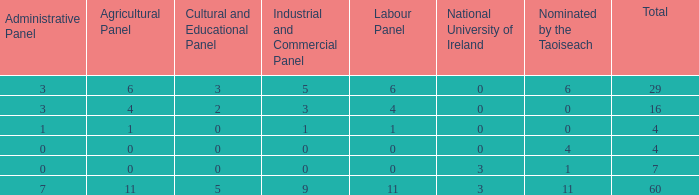What is the typical administrative committee of the composition designated by taoiseach 0 times with a total under 4? None. 